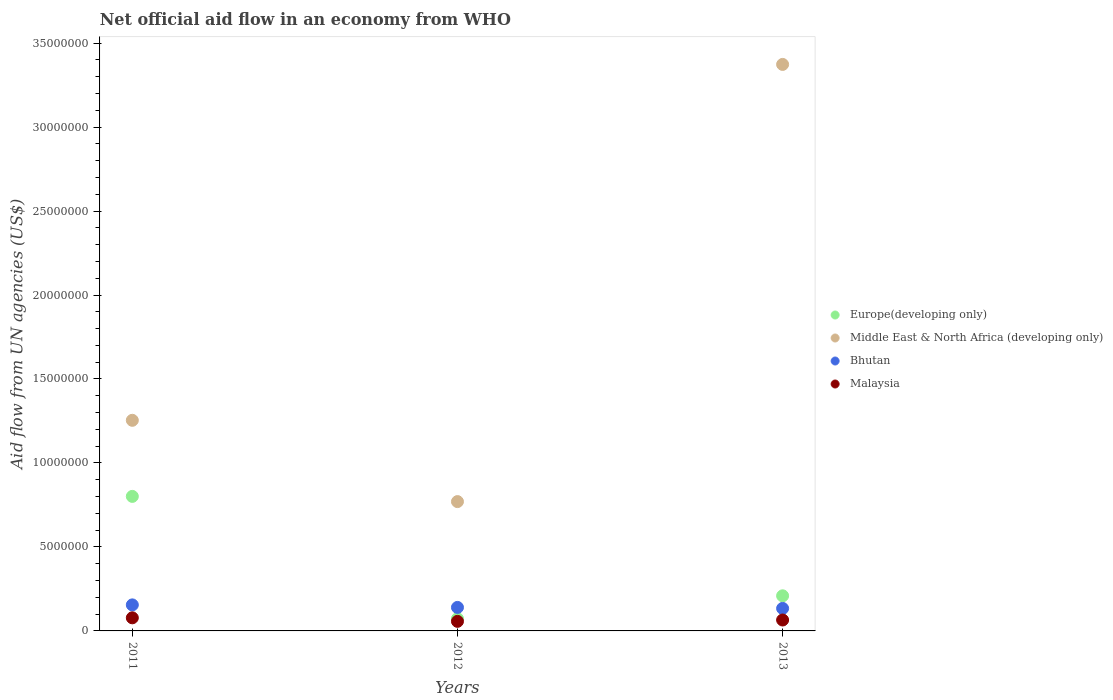How many different coloured dotlines are there?
Your answer should be very brief. 4. What is the net official aid flow in Middle East & North Africa (developing only) in 2012?
Offer a terse response. 7.70e+06. Across all years, what is the maximum net official aid flow in Bhutan?
Ensure brevity in your answer.  1.55e+06. Across all years, what is the minimum net official aid flow in Bhutan?
Offer a very short reply. 1.34e+06. In which year was the net official aid flow in Malaysia maximum?
Your answer should be compact. 2011. In which year was the net official aid flow in Malaysia minimum?
Keep it short and to the point. 2012. What is the total net official aid flow in Bhutan in the graph?
Keep it short and to the point. 4.29e+06. What is the difference between the net official aid flow in Malaysia in 2013 and the net official aid flow in Bhutan in 2012?
Offer a terse response. -7.50e+05. What is the average net official aid flow in Bhutan per year?
Give a very brief answer. 1.43e+06. In the year 2011, what is the difference between the net official aid flow in Europe(developing only) and net official aid flow in Middle East & North Africa (developing only)?
Provide a succinct answer. -4.53e+06. What is the ratio of the net official aid flow in Middle East & North Africa (developing only) in 2011 to that in 2013?
Your answer should be compact. 0.37. What is the difference between the highest and the second highest net official aid flow in Europe(developing only)?
Provide a short and direct response. 5.92e+06. What is the difference between the highest and the lowest net official aid flow in Malaysia?
Give a very brief answer. 2.10e+05. Does the graph contain grids?
Provide a short and direct response. No. What is the title of the graph?
Give a very brief answer. Net official aid flow in an economy from WHO. Does "Uruguay" appear as one of the legend labels in the graph?
Your answer should be very brief. No. What is the label or title of the Y-axis?
Ensure brevity in your answer.  Aid flow from UN agencies (US$). What is the Aid flow from UN agencies (US$) in Europe(developing only) in 2011?
Offer a terse response. 8.01e+06. What is the Aid flow from UN agencies (US$) of Middle East & North Africa (developing only) in 2011?
Offer a terse response. 1.25e+07. What is the Aid flow from UN agencies (US$) in Bhutan in 2011?
Offer a terse response. 1.55e+06. What is the Aid flow from UN agencies (US$) in Malaysia in 2011?
Provide a short and direct response. 7.80e+05. What is the Aid flow from UN agencies (US$) of Europe(developing only) in 2012?
Give a very brief answer. 7.30e+05. What is the Aid flow from UN agencies (US$) of Middle East & North Africa (developing only) in 2012?
Offer a terse response. 7.70e+06. What is the Aid flow from UN agencies (US$) of Bhutan in 2012?
Offer a terse response. 1.40e+06. What is the Aid flow from UN agencies (US$) in Malaysia in 2012?
Offer a terse response. 5.70e+05. What is the Aid flow from UN agencies (US$) of Europe(developing only) in 2013?
Your answer should be compact. 2.09e+06. What is the Aid flow from UN agencies (US$) in Middle East & North Africa (developing only) in 2013?
Give a very brief answer. 3.37e+07. What is the Aid flow from UN agencies (US$) in Bhutan in 2013?
Your answer should be very brief. 1.34e+06. What is the Aid flow from UN agencies (US$) in Malaysia in 2013?
Give a very brief answer. 6.50e+05. Across all years, what is the maximum Aid flow from UN agencies (US$) in Europe(developing only)?
Keep it short and to the point. 8.01e+06. Across all years, what is the maximum Aid flow from UN agencies (US$) of Middle East & North Africa (developing only)?
Your answer should be very brief. 3.37e+07. Across all years, what is the maximum Aid flow from UN agencies (US$) in Bhutan?
Make the answer very short. 1.55e+06. Across all years, what is the maximum Aid flow from UN agencies (US$) of Malaysia?
Your answer should be very brief. 7.80e+05. Across all years, what is the minimum Aid flow from UN agencies (US$) in Europe(developing only)?
Your answer should be compact. 7.30e+05. Across all years, what is the minimum Aid flow from UN agencies (US$) in Middle East & North Africa (developing only)?
Offer a terse response. 7.70e+06. Across all years, what is the minimum Aid flow from UN agencies (US$) of Bhutan?
Offer a terse response. 1.34e+06. Across all years, what is the minimum Aid flow from UN agencies (US$) of Malaysia?
Keep it short and to the point. 5.70e+05. What is the total Aid flow from UN agencies (US$) in Europe(developing only) in the graph?
Your response must be concise. 1.08e+07. What is the total Aid flow from UN agencies (US$) of Middle East & North Africa (developing only) in the graph?
Ensure brevity in your answer.  5.40e+07. What is the total Aid flow from UN agencies (US$) in Bhutan in the graph?
Provide a succinct answer. 4.29e+06. What is the difference between the Aid flow from UN agencies (US$) in Europe(developing only) in 2011 and that in 2012?
Provide a short and direct response. 7.28e+06. What is the difference between the Aid flow from UN agencies (US$) in Middle East & North Africa (developing only) in 2011 and that in 2012?
Provide a succinct answer. 4.84e+06. What is the difference between the Aid flow from UN agencies (US$) of Europe(developing only) in 2011 and that in 2013?
Provide a short and direct response. 5.92e+06. What is the difference between the Aid flow from UN agencies (US$) of Middle East & North Africa (developing only) in 2011 and that in 2013?
Give a very brief answer. -2.12e+07. What is the difference between the Aid flow from UN agencies (US$) of Bhutan in 2011 and that in 2013?
Give a very brief answer. 2.10e+05. What is the difference between the Aid flow from UN agencies (US$) of Malaysia in 2011 and that in 2013?
Make the answer very short. 1.30e+05. What is the difference between the Aid flow from UN agencies (US$) in Europe(developing only) in 2012 and that in 2013?
Your answer should be compact. -1.36e+06. What is the difference between the Aid flow from UN agencies (US$) in Middle East & North Africa (developing only) in 2012 and that in 2013?
Your answer should be compact. -2.60e+07. What is the difference between the Aid flow from UN agencies (US$) of Europe(developing only) in 2011 and the Aid flow from UN agencies (US$) of Bhutan in 2012?
Keep it short and to the point. 6.61e+06. What is the difference between the Aid flow from UN agencies (US$) in Europe(developing only) in 2011 and the Aid flow from UN agencies (US$) in Malaysia in 2012?
Keep it short and to the point. 7.44e+06. What is the difference between the Aid flow from UN agencies (US$) of Middle East & North Africa (developing only) in 2011 and the Aid flow from UN agencies (US$) of Bhutan in 2012?
Offer a terse response. 1.11e+07. What is the difference between the Aid flow from UN agencies (US$) in Middle East & North Africa (developing only) in 2011 and the Aid flow from UN agencies (US$) in Malaysia in 2012?
Ensure brevity in your answer.  1.20e+07. What is the difference between the Aid flow from UN agencies (US$) in Bhutan in 2011 and the Aid flow from UN agencies (US$) in Malaysia in 2012?
Give a very brief answer. 9.80e+05. What is the difference between the Aid flow from UN agencies (US$) of Europe(developing only) in 2011 and the Aid flow from UN agencies (US$) of Middle East & North Africa (developing only) in 2013?
Ensure brevity in your answer.  -2.57e+07. What is the difference between the Aid flow from UN agencies (US$) of Europe(developing only) in 2011 and the Aid flow from UN agencies (US$) of Bhutan in 2013?
Keep it short and to the point. 6.67e+06. What is the difference between the Aid flow from UN agencies (US$) in Europe(developing only) in 2011 and the Aid flow from UN agencies (US$) in Malaysia in 2013?
Give a very brief answer. 7.36e+06. What is the difference between the Aid flow from UN agencies (US$) of Middle East & North Africa (developing only) in 2011 and the Aid flow from UN agencies (US$) of Bhutan in 2013?
Your answer should be very brief. 1.12e+07. What is the difference between the Aid flow from UN agencies (US$) of Middle East & North Africa (developing only) in 2011 and the Aid flow from UN agencies (US$) of Malaysia in 2013?
Your answer should be compact. 1.19e+07. What is the difference between the Aid flow from UN agencies (US$) of Europe(developing only) in 2012 and the Aid flow from UN agencies (US$) of Middle East & North Africa (developing only) in 2013?
Your answer should be very brief. -3.30e+07. What is the difference between the Aid flow from UN agencies (US$) in Europe(developing only) in 2012 and the Aid flow from UN agencies (US$) in Bhutan in 2013?
Offer a terse response. -6.10e+05. What is the difference between the Aid flow from UN agencies (US$) of Middle East & North Africa (developing only) in 2012 and the Aid flow from UN agencies (US$) of Bhutan in 2013?
Ensure brevity in your answer.  6.36e+06. What is the difference between the Aid flow from UN agencies (US$) in Middle East & North Africa (developing only) in 2012 and the Aid flow from UN agencies (US$) in Malaysia in 2013?
Give a very brief answer. 7.05e+06. What is the difference between the Aid flow from UN agencies (US$) of Bhutan in 2012 and the Aid flow from UN agencies (US$) of Malaysia in 2013?
Give a very brief answer. 7.50e+05. What is the average Aid flow from UN agencies (US$) of Europe(developing only) per year?
Provide a short and direct response. 3.61e+06. What is the average Aid flow from UN agencies (US$) in Middle East & North Africa (developing only) per year?
Your response must be concise. 1.80e+07. What is the average Aid flow from UN agencies (US$) in Bhutan per year?
Your answer should be very brief. 1.43e+06. What is the average Aid flow from UN agencies (US$) in Malaysia per year?
Ensure brevity in your answer.  6.67e+05. In the year 2011, what is the difference between the Aid flow from UN agencies (US$) of Europe(developing only) and Aid flow from UN agencies (US$) of Middle East & North Africa (developing only)?
Your answer should be compact. -4.53e+06. In the year 2011, what is the difference between the Aid flow from UN agencies (US$) of Europe(developing only) and Aid flow from UN agencies (US$) of Bhutan?
Give a very brief answer. 6.46e+06. In the year 2011, what is the difference between the Aid flow from UN agencies (US$) in Europe(developing only) and Aid flow from UN agencies (US$) in Malaysia?
Keep it short and to the point. 7.23e+06. In the year 2011, what is the difference between the Aid flow from UN agencies (US$) of Middle East & North Africa (developing only) and Aid flow from UN agencies (US$) of Bhutan?
Your response must be concise. 1.10e+07. In the year 2011, what is the difference between the Aid flow from UN agencies (US$) in Middle East & North Africa (developing only) and Aid flow from UN agencies (US$) in Malaysia?
Offer a very short reply. 1.18e+07. In the year 2011, what is the difference between the Aid flow from UN agencies (US$) of Bhutan and Aid flow from UN agencies (US$) of Malaysia?
Provide a succinct answer. 7.70e+05. In the year 2012, what is the difference between the Aid flow from UN agencies (US$) in Europe(developing only) and Aid flow from UN agencies (US$) in Middle East & North Africa (developing only)?
Ensure brevity in your answer.  -6.97e+06. In the year 2012, what is the difference between the Aid flow from UN agencies (US$) in Europe(developing only) and Aid flow from UN agencies (US$) in Bhutan?
Your response must be concise. -6.70e+05. In the year 2012, what is the difference between the Aid flow from UN agencies (US$) of Europe(developing only) and Aid flow from UN agencies (US$) of Malaysia?
Your answer should be compact. 1.60e+05. In the year 2012, what is the difference between the Aid flow from UN agencies (US$) in Middle East & North Africa (developing only) and Aid flow from UN agencies (US$) in Bhutan?
Give a very brief answer. 6.30e+06. In the year 2012, what is the difference between the Aid flow from UN agencies (US$) of Middle East & North Africa (developing only) and Aid flow from UN agencies (US$) of Malaysia?
Your answer should be compact. 7.13e+06. In the year 2012, what is the difference between the Aid flow from UN agencies (US$) of Bhutan and Aid flow from UN agencies (US$) of Malaysia?
Offer a very short reply. 8.30e+05. In the year 2013, what is the difference between the Aid flow from UN agencies (US$) in Europe(developing only) and Aid flow from UN agencies (US$) in Middle East & North Africa (developing only)?
Offer a terse response. -3.16e+07. In the year 2013, what is the difference between the Aid flow from UN agencies (US$) in Europe(developing only) and Aid flow from UN agencies (US$) in Bhutan?
Your answer should be very brief. 7.50e+05. In the year 2013, what is the difference between the Aid flow from UN agencies (US$) of Europe(developing only) and Aid flow from UN agencies (US$) of Malaysia?
Ensure brevity in your answer.  1.44e+06. In the year 2013, what is the difference between the Aid flow from UN agencies (US$) of Middle East & North Africa (developing only) and Aid flow from UN agencies (US$) of Bhutan?
Make the answer very short. 3.24e+07. In the year 2013, what is the difference between the Aid flow from UN agencies (US$) in Middle East & North Africa (developing only) and Aid flow from UN agencies (US$) in Malaysia?
Your answer should be very brief. 3.31e+07. In the year 2013, what is the difference between the Aid flow from UN agencies (US$) in Bhutan and Aid flow from UN agencies (US$) in Malaysia?
Your answer should be very brief. 6.90e+05. What is the ratio of the Aid flow from UN agencies (US$) of Europe(developing only) in 2011 to that in 2012?
Give a very brief answer. 10.97. What is the ratio of the Aid flow from UN agencies (US$) of Middle East & North Africa (developing only) in 2011 to that in 2012?
Give a very brief answer. 1.63. What is the ratio of the Aid flow from UN agencies (US$) in Bhutan in 2011 to that in 2012?
Give a very brief answer. 1.11. What is the ratio of the Aid flow from UN agencies (US$) in Malaysia in 2011 to that in 2012?
Your response must be concise. 1.37. What is the ratio of the Aid flow from UN agencies (US$) in Europe(developing only) in 2011 to that in 2013?
Your response must be concise. 3.83. What is the ratio of the Aid flow from UN agencies (US$) of Middle East & North Africa (developing only) in 2011 to that in 2013?
Provide a succinct answer. 0.37. What is the ratio of the Aid flow from UN agencies (US$) of Bhutan in 2011 to that in 2013?
Offer a terse response. 1.16. What is the ratio of the Aid flow from UN agencies (US$) of Europe(developing only) in 2012 to that in 2013?
Keep it short and to the point. 0.35. What is the ratio of the Aid flow from UN agencies (US$) in Middle East & North Africa (developing only) in 2012 to that in 2013?
Your answer should be compact. 0.23. What is the ratio of the Aid flow from UN agencies (US$) in Bhutan in 2012 to that in 2013?
Keep it short and to the point. 1.04. What is the ratio of the Aid flow from UN agencies (US$) in Malaysia in 2012 to that in 2013?
Your answer should be compact. 0.88. What is the difference between the highest and the second highest Aid flow from UN agencies (US$) in Europe(developing only)?
Keep it short and to the point. 5.92e+06. What is the difference between the highest and the second highest Aid flow from UN agencies (US$) of Middle East & North Africa (developing only)?
Offer a terse response. 2.12e+07. What is the difference between the highest and the second highest Aid flow from UN agencies (US$) of Bhutan?
Keep it short and to the point. 1.50e+05. What is the difference between the highest and the lowest Aid flow from UN agencies (US$) of Europe(developing only)?
Offer a very short reply. 7.28e+06. What is the difference between the highest and the lowest Aid flow from UN agencies (US$) of Middle East & North Africa (developing only)?
Your answer should be compact. 2.60e+07. What is the difference between the highest and the lowest Aid flow from UN agencies (US$) in Malaysia?
Make the answer very short. 2.10e+05. 